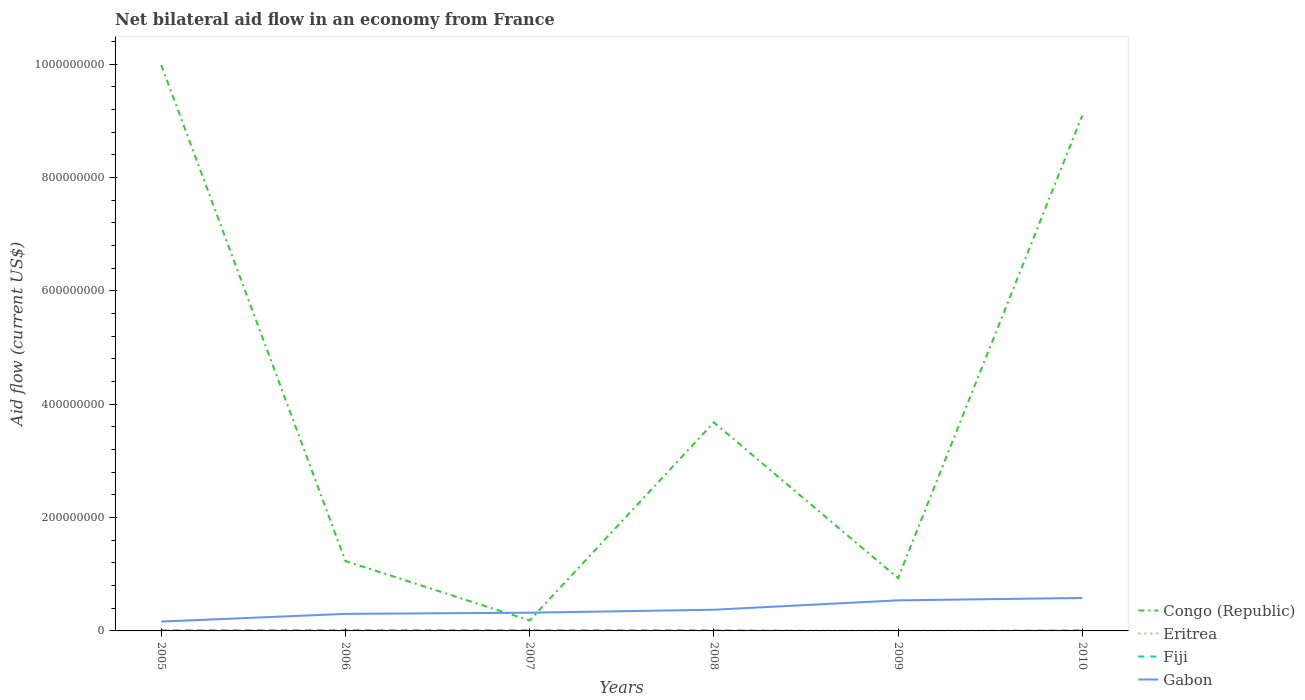Does the line corresponding to Fiji intersect with the line corresponding to Gabon?
Make the answer very short. No. Is the number of lines equal to the number of legend labels?
Give a very brief answer. No. Across all years, what is the maximum net bilateral aid flow in Fiji?
Your answer should be very brief. 0. What is the difference between the highest and the second highest net bilateral aid flow in Congo (Republic)?
Provide a short and direct response. 9.80e+08. What is the difference between the highest and the lowest net bilateral aid flow in Fiji?
Keep it short and to the point. 5. What is the difference between two consecutive major ticks on the Y-axis?
Your answer should be compact. 2.00e+08. How many legend labels are there?
Your answer should be compact. 4. What is the title of the graph?
Offer a very short reply. Net bilateral aid flow in an economy from France. What is the label or title of the Y-axis?
Ensure brevity in your answer.  Aid flow (current US$). What is the Aid flow (current US$) of Congo (Republic) in 2005?
Your answer should be very brief. 9.99e+08. What is the Aid flow (current US$) in Eritrea in 2005?
Offer a very short reply. 1.14e+06. What is the Aid flow (current US$) in Fiji in 2005?
Offer a very short reply. 1.02e+06. What is the Aid flow (current US$) in Gabon in 2005?
Offer a very short reply. 1.65e+07. What is the Aid flow (current US$) of Congo (Republic) in 2006?
Your response must be concise. 1.23e+08. What is the Aid flow (current US$) in Eritrea in 2006?
Offer a terse response. 8.50e+05. What is the Aid flow (current US$) of Fiji in 2006?
Your answer should be very brief. 1.29e+06. What is the Aid flow (current US$) in Gabon in 2006?
Your answer should be very brief. 3.01e+07. What is the Aid flow (current US$) of Congo (Republic) in 2007?
Provide a short and direct response. 1.85e+07. What is the Aid flow (current US$) in Eritrea in 2007?
Your response must be concise. 9.00e+05. What is the Aid flow (current US$) in Fiji in 2007?
Offer a terse response. 1.11e+06. What is the Aid flow (current US$) of Gabon in 2007?
Provide a succinct answer. 3.22e+07. What is the Aid flow (current US$) in Congo (Republic) in 2008?
Give a very brief answer. 3.68e+08. What is the Aid flow (current US$) in Eritrea in 2008?
Make the answer very short. 8.00e+05. What is the Aid flow (current US$) in Fiji in 2008?
Keep it short and to the point. 9.70e+05. What is the Aid flow (current US$) of Gabon in 2008?
Give a very brief answer. 3.74e+07. What is the Aid flow (current US$) of Congo (Republic) in 2009?
Keep it short and to the point. 9.32e+07. What is the Aid flow (current US$) in Eritrea in 2009?
Provide a short and direct response. 5.30e+05. What is the Aid flow (current US$) in Gabon in 2009?
Ensure brevity in your answer.  5.40e+07. What is the Aid flow (current US$) of Congo (Republic) in 2010?
Your answer should be very brief. 9.09e+08. What is the Aid flow (current US$) of Eritrea in 2010?
Keep it short and to the point. 6.50e+05. What is the Aid flow (current US$) in Fiji in 2010?
Make the answer very short. 9.70e+05. What is the Aid flow (current US$) of Gabon in 2010?
Your response must be concise. 5.81e+07. Across all years, what is the maximum Aid flow (current US$) of Congo (Republic)?
Offer a very short reply. 9.99e+08. Across all years, what is the maximum Aid flow (current US$) in Eritrea?
Offer a very short reply. 1.14e+06. Across all years, what is the maximum Aid flow (current US$) in Fiji?
Give a very brief answer. 1.29e+06. Across all years, what is the maximum Aid flow (current US$) in Gabon?
Make the answer very short. 5.81e+07. Across all years, what is the minimum Aid flow (current US$) of Congo (Republic)?
Provide a short and direct response. 1.85e+07. Across all years, what is the minimum Aid flow (current US$) in Eritrea?
Make the answer very short. 5.30e+05. Across all years, what is the minimum Aid flow (current US$) in Gabon?
Offer a terse response. 1.65e+07. What is the total Aid flow (current US$) in Congo (Republic) in the graph?
Offer a terse response. 2.51e+09. What is the total Aid flow (current US$) of Eritrea in the graph?
Offer a very short reply. 4.87e+06. What is the total Aid flow (current US$) in Fiji in the graph?
Ensure brevity in your answer.  5.36e+06. What is the total Aid flow (current US$) in Gabon in the graph?
Offer a terse response. 2.28e+08. What is the difference between the Aid flow (current US$) of Congo (Republic) in 2005 and that in 2006?
Your response must be concise. 8.75e+08. What is the difference between the Aid flow (current US$) of Fiji in 2005 and that in 2006?
Give a very brief answer. -2.70e+05. What is the difference between the Aid flow (current US$) in Gabon in 2005 and that in 2006?
Make the answer very short. -1.36e+07. What is the difference between the Aid flow (current US$) of Congo (Republic) in 2005 and that in 2007?
Offer a terse response. 9.80e+08. What is the difference between the Aid flow (current US$) in Eritrea in 2005 and that in 2007?
Make the answer very short. 2.40e+05. What is the difference between the Aid flow (current US$) of Fiji in 2005 and that in 2007?
Keep it short and to the point. -9.00e+04. What is the difference between the Aid flow (current US$) in Gabon in 2005 and that in 2007?
Provide a short and direct response. -1.56e+07. What is the difference between the Aid flow (current US$) of Congo (Republic) in 2005 and that in 2008?
Make the answer very short. 6.31e+08. What is the difference between the Aid flow (current US$) of Gabon in 2005 and that in 2008?
Give a very brief answer. -2.09e+07. What is the difference between the Aid flow (current US$) of Congo (Republic) in 2005 and that in 2009?
Make the answer very short. 9.06e+08. What is the difference between the Aid flow (current US$) of Gabon in 2005 and that in 2009?
Make the answer very short. -3.74e+07. What is the difference between the Aid flow (current US$) in Congo (Republic) in 2005 and that in 2010?
Provide a short and direct response. 8.93e+07. What is the difference between the Aid flow (current US$) of Eritrea in 2005 and that in 2010?
Provide a succinct answer. 4.90e+05. What is the difference between the Aid flow (current US$) of Gabon in 2005 and that in 2010?
Provide a short and direct response. -4.16e+07. What is the difference between the Aid flow (current US$) of Congo (Republic) in 2006 and that in 2007?
Your answer should be very brief. 1.05e+08. What is the difference between the Aid flow (current US$) of Eritrea in 2006 and that in 2007?
Provide a succinct answer. -5.00e+04. What is the difference between the Aid flow (current US$) in Gabon in 2006 and that in 2007?
Keep it short and to the point. -2.08e+06. What is the difference between the Aid flow (current US$) of Congo (Republic) in 2006 and that in 2008?
Provide a succinct answer. -2.45e+08. What is the difference between the Aid flow (current US$) in Gabon in 2006 and that in 2008?
Give a very brief answer. -7.35e+06. What is the difference between the Aid flow (current US$) in Congo (Republic) in 2006 and that in 2009?
Offer a terse response. 3.02e+07. What is the difference between the Aid flow (current US$) in Gabon in 2006 and that in 2009?
Ensure brevity in your answer.  -2.39e+07. What is the difference between the Aid flow (current US$) of Congo (Republic) in 2006 and that in 2010?
Your answer should be very brief. -7.86e+08. What is the difference between the Aid flow (current US$) of Gabon in 2006 and that in 2010?
Keep it short and to the point. -2.81e+07. What is the difference between the Aid flow (current US$) in Congo (Republic) in 2007 and that in 2008?
Offer a terse response. -3.49e+08. What is the difference between the Aid flow (current US$) in Eritrea in 2007 and that in 2008?
Keep it short and to the point. 1.00e+05. What is the difference between the Aid flow (current US$) in Fiji in 2007 and that in 2008?
Make the answer very short. 1.40e+05. What is the difference between the Aid flow (current US$) of Gabon in 2007 and that in 2008?
Keep it short and to the point. -5.27e+06. What is the difference between the Aid flow (current US$) in Congo (Republic) in 2007 and that in 2009?
Provide a succinct answer. -7.46e+07. What is the difference between the Aid flow (current US$) in Gabon in 2007 and that in 2009?
Your answer should be compact. -2.18e+07. What is the difference between the Aid flow (current US$) of Congo (Republic) in 2007 and that in 2010?
Provide a short and direct response. -8.91e+08. What is the difference between the Aid flow (current US$) in Eritrea in 2007 and that in 2010?
Provide a succinct answer. 2.50e+05. What is the difference between the Aid flow (current US$) in Gabon in 2007 and that in 2010?
Keep it short and to the point. -2.60e+07. What is the difference between the Aid flow (current US$) of Congo (Republic) in 2008 and that in 2009?
Provide a short and direct response. 2.75e+08. What is the difference between the Aid flow (current US$) in Eritrea in 2008 and that in 2009?
Offer a very short reply. 2.70e+05. What is the difference between the Aid flow (current US$) of Gabon in 2008 and that in 2009?
Your answer should be compact. -1.65e+07. What is the difference between the Aid flow (current US$) in Congo (Republic) in 2008 and that in 2010?
Your response must be concise. -5.41e+08. What is the difference between the Aid flow (current US$) of Eritrea in 2008 and that in 2010?
Ensure brevity in your answer.  1.50e+05. What is the difference between the Aid flow (current US$) of Fiji in 2008 and that in 2010?
Ensure brevity in your answer.  0. What is the difference between the Aid flow (current US$) in Gabon in 2008 and that in 2010?
Give a very brief answer. -2.07e+07. What is the difference between the Aid flow (current US$) in Congo (Republic) in 2009 and that in 2010?
Offer a terse response. -8.16e+08. What is the difference between the Aid flow (current US$) of Gabon in 2009 and that in 2010?
Your answer should be compact. -4.18e+06. What is the difference between the Aid flow (current US$) of Congo (Republic) in 2005 and the Aid flow (current US$) of Eritrea in 2006?
Your answer should be compact. 9.98e+08. What is the difference between the Aid flow (current US$) in Congo (Republic) in 2005 and the Aid flow (current US$) in Fiji in 2006?
Make the answer very short. 9.97e+08. What is the difference between the Aid flow (current US$) of Congo (Republic) in 2005 and the Aid flow (current US$) of Gabon in 2006?
Make the answer very short. 9.69e+08. What is the difference between the Aid flow (current US$) of Eritrea in 2005 and the Aid flow (current US$) of Gabon in 2006?
Offer a terse response. -2.89e+07. What is the difference between the Aid flow (current US$) of Fiji in 2005 and the Aid flow (current US$) of Gabon in 2006?
Provide a short and direct response. -2.90e+07. What is the difference between the Aid flow (current US$) in Congo (Republic) in 2005 and the Aid flow (current US$) in Eritrea in 2007?
Your answer should be very brief. 9.98e+08. What is the difference between the Aid flow (current US$) of Congo (Republic) in 2005 and the Aid flow (current US$) of Fiji in 2007?
Your response must be concise. 9.98e+08. What is the difference between the Aid flow (current US$) in Congo (Republic) in 2005 and the Aid flow (current US$) in Gabon in 2007?
Provide a succinct answer. 9.67e+08. What is the difference between the Aid flow (current US$) in Eritrea in 2005 and the Aid flow (current US$) in Gabon in 2007?
Ensure brevity in your answer.  -3.10e+07. What is the difference between the Aid flow (current US$) of Fiji in 2005 and the Aid flow (current US$) of Gabon in 2007?
Your answer should be compact. -3.11e+07. What is the difference between the Aid flow (current US$) of Congo (Republic) in 2005 and the Aid flow (current US$) of Eritrea in 2008?
Offer a terse response. 9.98e+08. What is the difference between the Aid flow (current US$) of Congo (Republic) in 2005 and the Aid flow (current US$) of Fiji in 2008?
Your answer should be very brief. 9.98e+08. What is the difference between the Aid flow (current US$) in Congo (Republic) in 2005 and the Aid flow (current US$) in Gabon in 2008?
Your response must be concise. 9.61e+08. What is the difference between the Aid flow (current US$) in Eritrea in 2005 and the Aid flow (current US$) in Gabon in 2008?
Offer a very short reply. -3.63e+07. What is the difference between the Aid flow (current US$) in Fiji in 2005 and the Aid flow (current US$) in Gabon in 2008?
Make the answer very short. -3.64e+07. What is the difference between the Aid flow (current US$) of Congo (Republic) in 2005 and the Aid flow (current US$) of Eritrea in 2009?
Your response must be concise. 9.98e+08. What is the difference between the Aid flow (current US$) in Congo (Republic) in 2005 and the Aid flow (current US$) in Gabon in 2009?
Provide a short and direct response. 9.45e+08. What is the difference between the Aid flow (current US$) in Eritrea in 2005 and the Aid flow (current US$) in Gabon in 2009?
Provide a short and direct response. -5.28e+07. What is the difference between the Aid flow (current US$) of Fiji in 2005 and the Aid flow (current US$) of Gabon in 2009?
Ensure brevity in your answer.  -5.29e+07. What is the difference between the Aid flow (current US$) of Congo (Republic) in 2005 and the Aid flow (current US$) of Eritrea in 2010?
Offer a terse response. 9.98e+08. What is the difference between the Aid flow (current US$) in Congo (Republic) in 2005 and the Aid flow (current US$) in Fiji in 2010?
Offer a very short reply. 9.98e+08. What is the difference between the Aid flow (current US$) in Congo (Republic) in 2005 and the Aid flow (current US$) in Gabon in 2010?
Offer a terse response. 9.41e+08. What is the difference between the Aid flow (current US$) of Eritrea in 2005 and the Aid flow (current US$) of Gabon in 2010?
Your answer should be compact. -5.70e+07. What is the difference between the Aid flow (current US$) of Fiji in 2005 and the Aid flow (current US$) of Gabon in 2010?
Your response must be concise. -5.71e+07. What is the difference between the Aid flow (current US$) of Congo (Republic) in 2006 and the Aid flow (current US$) of Eritrea in 2007?
Ensure brevity in your answer.  1.22e+08. What is the difference between the Aid flow (current US$) of Congo (Republic) in 2006 and the Aid flow (current US$) of Fiji in 2007?
Your answer should be compact. 1.22e+08. What is the difference between the Aid flow (current US$) in Congo (Republic) in 2006 and the Aid flow (current US$) in Gabon in 2007?
Keep it short and to the point. 9.12e+07. What is the difference between the Aid flow (current US$) in Eritrea in 2006 and the Aid flow (current US$) in Gabon in 2007?
Keep it short and to the point. -3.13e+07. What is the difference between the Aid flow (current US$) in Fiji in 2006 and the Aid flow (current US$) in Gabon in 2007?
Offer a very short reply. -3.09e+07. What is the difference between the Aid flow (current US$) in Congo (Republic) in 2006 and the Aid flow (current US$) in Eritrea in 2008?
Provide a succinct answer. 1.23e+08. What is the difference between the Aid flow (current US$) in Congo (Republic) in 2006 and the Aid flow (current US$) in Fiji in 2008?
Give a very brief answer. 1.22e+08. What is the difference between the Aid flow (current US$) in Congo (Republic) in 2006 and the Aid flow (current US$) in Gabon in 2008?
Provide a short and direct response. 8.60e+07. What is the difference between the Aid flow (current US$) of Eritrea in 2006 and the Aid flow (current US$) of Gabon in 2008?
Ensure brevity in your answer.  -3.66e+07. What is the difference between the Aid flow (current US$) of Fiji in 2006 and the Aid flow (current US$) of Gabon in 2008?
Give a very brief answer. -3.61e+07. What is the difference between the Aid flow (current US$) of Congo (Republic) in 2006 and the Aid flow (current US$) of Eritrea in 2009?
Your answer should be very brief. 1.23e+08. What is the difference between the Aid flow (current US$) of Congo (Republic) in 2006 and the Aid flow (current US$) of Gabon in 2009?
Your answer should be compact. 6.94e+07. What is the difference between the Aid flow (current US$) of Eritrea in 2006 and the Aid flow (current US$) of Gabon in 2009?
Ensure brevity in your answer.  -5.31e+07. What is the difference between the Aid flow (current US$) of Fiji in 2006 and the Aid flow (current US$) of Gabon in 2009?
Provide a short and direct response. -5.27e+07. What is the difference between the Aid flow (current US$) of Congo (Republic) in 2006 and the Aid flow (current US$) of Eritrea in 2010?
Your answer should be compact. 1.23e+08. What is the difference between the Aid flow (current US$) of Congo (Republic) in 2006 and the Aid flow (current US$) of Fiji in 2010?
Give a very brief answer. 1.22e+08. What is the difference between the Aid flow (current US$) in Congo (Republic) in 2006 and the Aid flow (current US$) in Gabon in 2010?
Offer a very short reply. 6.52e+07. What is the difference between the Aid flow (current US$) in Eritrea in 2006 and the Aid flow (current US$) in Gabon in 2010?
Your answer should be compact. -5.73e+07. What is the difference between the Aid flow (current US$) of Fiji in 2006 and the Aid flow (current US$) of Gabon in 2010?
Your response must be concise. -5.68e+07. What is the difference between the Aid flow (current US$) in Congo (Republic) in 2007 and the Aid flow (current US$) in Eritrea in 2008?
Provide a succinct answer. 1.77e+07. What is the difference between the Aid flow (current US$) in Congo (Republic) in 2007 and the Aid flow (current US$) in Fiji in 2008?
Give a very brief answer. 1.76e+07. What is the difference between the Aid flow (current US$) of Congo (Republic) in 2007 and the Aid flow (current US$) of Gabon in 2008?
Your answer should be compact. -1.89e+07. What is the difference between the Aid flow (current US$) in Eritrea in 2007 and the Aid flow (current US$) in Fiji in 2008?
Your answer should be very brief. -7.00e+04. What is the difference between the Aid flow (current US$) of Eritrea in 2007 and the Aid flow (current US$) of Gabon in 2008?
Ensure brevity in your answer.  -3.65e+07. What is the difference between the Aid flow (current US$) in Fiji in 2007 and the Aid flow (current US$) in Gabon in 2008?
Give a very brief answer. -3.63e+07. What is the difference between the Aid flow (current US$) of Congo (Republic) in 2007 and the Aid flow (current US$) of Eritrea in 2009?
Your answer should be very brief. 1.80e+07. What is the difference between the Aid flow (current US$) in Congo (Republic) in 2007 and the Aid flow (current US$) in Gabon in 2009?
Provide a short and direct response. -3.54e+07. What is the difference between the Aid flow (current US$) in Eritrea in 2007 and the Aid flow (current US$) in Gabon in 2009?
Your answer should be compact. -5.30e+07. What is the difference between the Aid flow (current US$) of Fiji in 2007 and the Aid flow (current US$) of Gabon in 2009?
Provide a succinct answer. -5.28e+07. What is the difference between the Aid flow (current US$) of Congo (Republic) in 2007 and the Aid flow (current US$) of Eritrea in 2010?
Make the answer very short. 1.79e+07. What is the difference between the Aid flow (current US$) of Congo (Republic) in 2007 and the Aid flow (current US$) of Fiji in 2010?
Give a very brief answer. 1.76e+07. What is the difference between the Aid flow (current US$) in Congo (Republic) in 2007 and the Aid flow (current US$) in Gabon in 2010?
Offer a terse response. -3.96e+07. What is the difference between the Aid flow (current US$) in Eritrea in 2007 and the Aid flow (current US$) in Gabon in 2010?
Offer a terse response. -5.72e+07. What is the difference between the Aid flow (current US$) in Fiji in 2007 and the Aid flow (current US$) in Gabon in 2010?
Keep it short and to the point. -5.70e+07. What is the difference between the Aid flow (current US$) in Congo (Republic) in 2008 and the Aid flow (current US$) in Eritrea in 2009?
Your answer should be very brief. 3.67e+08. What is the difference between the Aid flow (current US$) of Congo (Republic) in 2008 and the Aid flow (current US$) of Gabon in 2009?
Provide a succinct answer. 3.14e+08. What is the difference between the Aid flow (current US$) of Eritrea in 2008 and the Aid flow (current US$) of Gabon in 2009?
Give a very brief answer. -5.32e+07. What is the difference between the Aid flow (current US$) of Fiji in 2008 and the Aid flow (current US$) of Gabon in 2009?
Provide a succinct answer. -5.30e+07. What is the difference between the Aid flow (current US$) of Congo (Republic) in 2008 and the Aid flow (current US$) of Eritrea in 2010?
Your answer should be very brief. 3.67e+08. What is the difference between the Aid flow (current US$) in Congo (Republic) in 2008 and the Aid flow (current US$) in Fiji in 2010?
Provide a short and direct response. 3.67e+08. What is the difference between the Aid flow (current US$) in Congo (Republic) in 2008 and the Aid flow (current US$) in Gabon in 2010?
Your answer should be very brief. 3.10e+08. What is the difference between the Aid flow (current US$) of Eritrea in 2008 and the Aid flow (current US$) of Gabon in 2010?
Ensure brevity in your answer.  -5.73e+07. What is the difference between the Aid flow (current US$) in Fiji in 2008 and the Aid flow (current US$) in Gabon in 2010?
Provide a short and direct response. -5.72e+07. What is the difference between the Aid flow (current US$) in Congo (Republic) in 2009 and the Aid flow (current US$) in Eritrea in 2010?
Offer a terse response. 9.25e+07. What is the difference between the Aid flow (current US$) in Congo (Republic) in 2009 and the Aid flow (current US$) in Fiji in 2010?
Provide a short and direct response. 9.22e+07. What is the difference between the Aid flow (current US$) in Congo (Republic) in 2009 and the Aid flow (current US$) in Gabon in 2010?
Keep it short and to the point. 3.50e+07. What is the difference between the Aid flow (current US$) of Eritrea in 2009 and the Aid flow (current US$) of Fiji in 2010?
Provide a succinct answer. -4.40e+05. What is the difference between the Aid flow (current US$) of Eritrea in 2009 and the Aid flow (current US$) of Gabon in 2010?
Offer a terse response. -5.76e+07. What is the average Aid flow (current US$) in Congo (Republic) per year?
Your answer should be compact. 4.19e+08. What is the average Aid flow (current US$) of Eritrea per year?
Your answer should be very brief. 8.12e+05. What is the average Aid flow (current US$) of Fiji per year?
Your answer should be very brief. 8.93e+05. What is the average Aid flow (current US$) of Gabon per year?
Your answer should be very brief. 3.80e+07. In the year 2005, what is the difference between the Aid flow (current US$) in Congo (Republic) and Aid flow (current US$) in Eritrea?
Offer a very short reply. 9.98e+08. In the year 2005, what is the difference between the Aid flow (current US$) in Congo (Republic) and Aid flow (current US$) in Fiji?
Offer a terse response. 9.98e+08. In the year 2005, what is the difference between the Aid flow (current US$) in Congo (Republic) and Aid flow (current US$) in Gabon?
Ensure brevity in your answer.  9.82e+08. In the year 2005, what is the difference between the Aid flow (current US$) in Eritrea and Aid flow (current US$) in Fiji?
Make the answer very short. 1.20e+05. In the year 2005, what is the difference between the Aid flow (current US$) in Eritrea and Aid flow (current US$) in Gabon?
Ensure brevity in your answer.  -1.54e+07. In the year 2005, what is the difference between the Aid flow (current US$) in Fiji and Aid flow (current US$) in Gabon?
Offer a terse response. -1.55e+07. In the year 2006, what is the difference between the Aid flow (current US$) in Congo (Republic) and Aid flow (current US$) in Eritrea?
Keep it short and to the point. 1.23e+08. In the year 2006, what is the difference between the Aid flow (current US$) in Congo (Republic) and Aid flow (current US$) in Fiji?
Provide a short and direct response. 1.22e+08. In the year 2006, what is the difference between the Aid flow (current US$) of Congo (Republic) and Aid flow (current US$) of Gabon?
Your response must be concise. 9.33e+07. In the year 2006, what is the difference between the Aid flow (current US$) in Eritrea and Aid flow (current US$) in Fiji?
Ensure brevity in your answer.  -4.40e+05. In the year 2006, what is the difference between the Aid flow (current US$) in Eritrea and Aid flow (current US$) in Gabon?
Keep it short and to the point. -2.92e+07. In the year 2006, what is the difference between the Aid flow (current US$) of Fiji and Aid flow (current US$) of Gabon?
Keep it short and to the point. -2.88e+07. In the year 2007, what is the difference between the Aid flow (current US$) of Congo (Republic) and Aid flow (current US$) of Eritrea?
Ensure brevity in your answer.  1.76e+07. In the year 2007, what is the difference between the Aid flow (current US$) in Congo (Republic) and Aid flow (current US$) in Fiji?
Offer a very short reply. 1.74e+07. In the year 2007, what is the difference between the Aid flow (current US$) in Congo (Republic) and Aid flow (current US$) in Gabon?
Ensure brevity in your answer.  -1.36e+07. In the year 2007, what is the difference between the Aid flow (current US$) in Eritrea and Aid flow (current US$) in Fiji?
Ensure brevity in your answer.  -2.10e+05. In the year 2007, what is the difference between the Aid flow (current US$) in Eritrea and Aid flow (current US$) in Gabon?
Provide a short and direct response. -3.12e+07. In the year 2007, what is the difference between the Aid flow (current US$) of Fiji and Aid flow (current US$) of Gabon?
Keep it short and to the point. -3.10e+07. In the year 2008, what is the difference between the Aid flow (current US$) in Congo (Republic) and Aid flow (current US$) in Eritrea?
Provide a succinct answer. 3.67e+08. In the year 2008, what is the difference between the Aid flow (current US$) of Congo (Republic) and Aid flow (current US$) of Fiji?
Your answer should be very brief. 3.67e+08. In the year 2008, what is the difference between the Aid flow (current US$) in Congo (Republic) and Aid flow (current US$) in Gabon?
Ensure brevity in your answer.  3.31e+08. In the year 2008, what is the difference between the Aid flow (current US$) of Eritrea and Aid flow (current US$) of Gabon?
Make the answer very short. -3.66e+07. In the year 2008, what is the difference between the Aid flow (current US$) of Fiji and Aid flow (current US$) of Gabon?
Your answer should be compact. -3.64e+07. In the year 2009, what is the difference between the Aid flow (current US$) in Congo (Republic) and Aid flow (current US$) in Eritrea?
Your answer should be compact. 9.26e+07. In the year 2009, what is the difference between the Aid flow (current US$) of Congo (Republic) and Aid flow (current US$) of Gabon?
Keep it short and to the point. 3.92e+07. In the year 2009, what is the difference between the Aid flow (current US$) in Eritrea and Aid flow (current US$) in Gabon?
Your response must be concise. -5.34e+07. In the year 2010, what is the difference between the Aid flow (current US$) in Congo (Republic) and Aid flow (current US$) in Eritrea?
Offer a very short reply. 9.09e+08. In the year 2010, what is the difference between the Aid flow (current US$) in Congo (Republic) and Aid flow (current US$) in Fiji?
Offer a terse response. 9.08e+08. In the year 2010, what is the difference between the Aid flow (current US$) of Congo (Republic) and Aid flow (current US$) of Gabon?
Provide a succinct answer. 8.51e+08. In the year 2010, what is the difference between the Aid flow (current US$) of Eritrea and Aid flow (current US$) of Fiji?
Provide a succinct answer. -3.20e+05. In the year 2010, what is the difference between the Aid flow (current US$) in Eritrea and Aid flow (current US$) in Gabon?
Ensure brevity in your answer.  -5.75e+07. In the year 2010, what is the difference between the Aid flow (current US$) in Fiji and Aid flow (current US$) in Gabon?
Your answer should be very brief. -5.72e+07. What is the ratio of the Aid flow (current US$) of Congo (Republic) in 2005 to that in 2006?
Provide a short and direct response. 8.09. What is the ratio of the Aid flow (current US$) in Eritrea in 2005 to that in 2006?
Your answer should be compact. 1.34. What is the ratio of the Aid flow (current US$) of Fiji in 2005 to that in 2006?
Make the answer very short. 0.79. What is the ratio of the Aid flow (current US$) in Gabon in 2005 to that in 2006?
Give a very brief answer. 0.55. What is the ratio of the Aid flow (current US$) of Congo (Republic) in 2005 to that in 2007?
Make the answer very short. 53.93. What is the ratio of the Aid flow (current US$) in Eritrea in 2005 to that in 2007?
Offer a terse response. 1.27. What is the ratio of the Aid flow (current US$) of Fiji in 2005 to that in 2007?
Keep it short and to the point. 0.92. What is the ratio of the Aid flow (current US$) in Gabon in 2005 to that in 2007?
Offer a terse response. 0.51. What is the ratio of the Aid flow (current US$) of Congo (Republic) in 2005 to that in 2008?
Give a very brief answer. 2.71. What is the ratio of the Aid flow (current US$) of Eritrea in 2005 to that in 2008?
Provide a short and direct response. 1.43. What is the ratio of the Aid flow (current US$) of Fiji in 2005 to that in 2008?
Offer a very short reply. 1.05. What is the ratio of the Aid flow (current US$) of Gabon in 2005 to that in 2008?
Your answer should be compact. 0.44. What is the ratio of the Aid flow (current US$) in Congo (Republic) in 2005 to that in 2009?
Ensure brevity in your answer.  10.72. What is the ratio of the Aid flow (current US$) of Eritrea in 2005 to that in 2009?
Your answer should be compact. 2.15. What is the ratio of the Aid flow (current US$) of Gabon in 2005 to that in 2009?
Make the answer very short. 0.31. What is the ratio of the Aid flow (current US$) of Congo (Republic) in 2005 to that in 2010?
Provide a short and direct response. 1.1. What is the ratio of the Aid flow (current US$) of Eritrea in 2005 to that in 2010?
Make the answer very short. 1.75. What is the ratio of the Aid flow (current US$) of Fiji in 2005 to that in 2010?
Your response must be concise. 1.05. What is the ratio of the Aid flow (current US$) in Gabon in 2005 to that in 2010?
Provide a succinct answer. 0.28. What is the ratio of the Aid flow (current US$) in Congo (Republic) in 2006 to that in 2007?
Offer a very short reply. 6.66. What is the ratio of the Aid flow (current US$) in Fiji in 2006 to that in 2007?
Give a very brief answer. 1.16. What is the ratio of the Aid flow (current US$) in Gabon in 2006 to that in 2007?
Provide a short and direct response. 0.94. What is the ratio of the Aid flow (current US$) of Congo (Republic) in 2006 to that in 2008?
Ensure brevity in your answer.  0.34. What is the ratio of the Aid flow (current US$) of Fiji in 2006 to that in 2008?
Your response must be concise. 1.33. What is the ratio of the Aid flow (current US$) of Gabon in 2006 to that in 2008?
Offer a terse response. 0.8. What is the ratio of the Aid flow (current US$) of Congo (Republic) in 2006 to that in 2009?
Offer a very short reply. 1.32. What is the ratio of the Aid flow (current US$) in Eritrea in 2006 to that in 2009?
Keep it short and to the point. 1.6. What is the ratio of the Aid flow (current US$) of Gabon in 2006 to that in 2009?
Your answer should be very brief. 0.56. What is the ratio of the Aid flow (current US$) of Congo (Republic) in 2006 to that in 2010?
Make the answer very short. 0.14. What is the ratio of the Aid flow (current US$) in Eritrea in 2006 to that in 2010?
Provide a succinct answer. 1.31. What is the ratio of the Aid flow (current US$) in Fiji in 2006 to that in 2010?
Your response must be concise. 1.33. What is the ratio of the Aid flow (current US$) in Gabon in 2006 to that in 2010?
Keep it short and to the point. 0.52. What is the ratio of the Aid flow (current US$) in Congo (Republic) in 2007 to that in 2008?
Offer a very short reply. 0.05. What is the ratio of the Aid flow (current US$) of Fiji in 2007 to that in 2008?
Your answer should be compact. 1.14. What is the ratio of the Aid flow (current US$) in Gabon in 2007 to that in 2008?
Offer a terse response. 0.86. What is the ratio of the Aid flow (current US$) of Congo (Republic) in 2007 to that in 2009?
Provide a short and direct response. 0.2. What is the ratio of the Aid flow (current US$) of Eritrea in 2007 to that in 2009?
Provide a succinct answer. 1.7. What is the ratio of the Aid flow (current US$) of Gabon in 2007 to that in 2009?
Your response must be concise. 0.6. What is the ratio of the Aid flow (current US$) in Congo (Republic) in 2007 to that in 2010?
Keep it short and to the point. 0.02. What is the ratio of the Aid flow (current US$) of Eritrea in 2007 to that in 2010?
Provide a short and direct response. 1.38. What is the ratio of the Aid flow (current US$) of Fiji in 2007 to that in 2010?
Make the answer very short. 1.14. What is the ratio of the Aid flow (current US$) in Gabon in 2007 to that in 2010?
Your response must be concise. 0.55. What is the ratio of the Aid flow (current US$) in Congo (Republic) in 2008 to that in 2009?
Your answer should be very brief. 3.95. What is the ratio of the Aid flow (current US$) in Eritrea in 2008 to that in 2009?
Offer a terse response. 1.51. What is the ratio of the Aid flow (current US$) in Gabon in 2008 to that in 2009?
Your answer should be very brief. 0.69. What is the ratio of the Aid flow (current US$) of Congo (Republic) in 2008 to that in 2010?
Give a very brief answer. 0.4. What is the ratio of the Aid flow (current US$) of Eritrea in 2008 to that in 2010?
Give a very brief answer. 1.23. What is the ratio of the Aid flow (current US$) of Fiji in 2008 to that in 2010?
Your answer should be very brief. 1. What is the ratio of the Aid flow (current US$) in Gabon in 2008 to that in 2010?
Offer a terse response. 0.64. What is the ratio of the Aid flow (current US$) of Congo (Republic) in 2009 to that in 2010?
Provide a short and direct response. 0.1. What is the ratio of the Aid flow (current US$) of Eritrea in 2009 to that in 2010?
Your answer should be compact. 0.82. What is the ratio of the Aid flow (current US$) in Gabon in 2009 to that in 2010?
Keep it short and to the point. 0.93. What is the difference between the highest and the second highest Aid flow (current US$) of Congo (Republic)?
Your response must be concise. 8.93e+07. What is the difference between the highest and the second highest Aid flow (current US$) of Eritrea?
Give a very brief answer. 2.40e+05. What is the difference between the highest and the second highest Aid flow (current US$) in Gabon?
Ensure brevity in your answer.  4.18e+06. What is the difference between the highest and the lowest Aid flow (current US$) in Congo (Republic)?
Your response must be concise. 9.80e+08. What is the difference between the highest and the lowest Aid flow (current US$) of Eritrea?
Your answer should be compact. 6.10e+05. What is the difference between the highest and the lowest Aid flow (current US$) of Fiji?
Provide a succinct answer. 1.29e+06. What is the difference between the highest and the lowest Aid flow (current US$) of Gabon?
Give a very brief answer. 4.16e+07. 